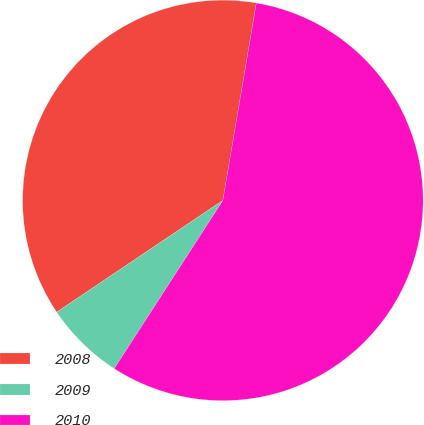<chart> <loc_0><loc_0><loc_500><loc_500><pie_chart><fcel>2008<fcel>2009<fcel>2010<nl><fcel>37.1%<fcel>6.45%<fcel>56.45%<nl></chart> 